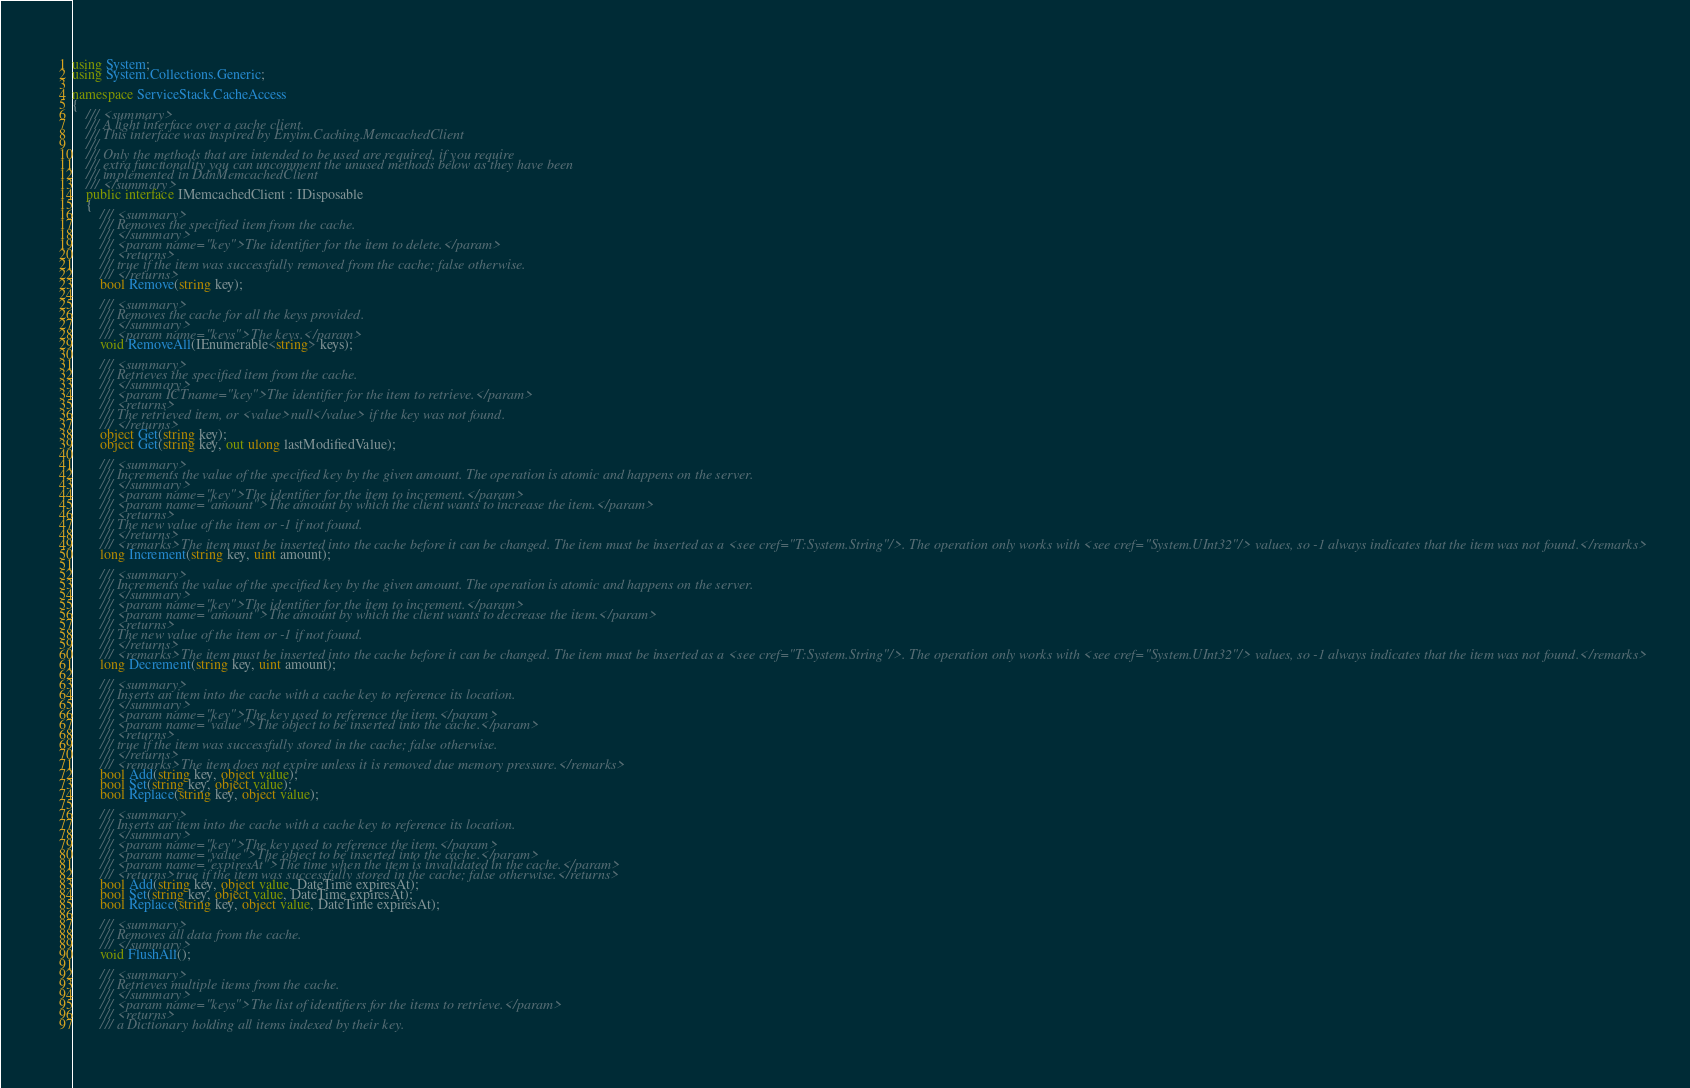Convert code to text. <code><loc_0><loc_0><loc_500><loc_500><_C#_>using System;
using System.Collections.Generic;

namespace ServiceStack.CacheAccess
{
	/// <summary>
	/// A light interface over a cache client.
	/// This interface was inspired by Enyim.Caching.MemcachedClient
	/// 
	/// Only the methods that are intended to be used are required, if you require
	/// extra functionality you can uncomment the unused methods below as they have been
	/// implemented in DdnMemcachedClient
	/// </summary>
	public interface IMemcachedClient : IDisposable
	{
		/// <summary>
		/// Removes the specified item from the cache.
		/// </summary>
		/// <param name="key">The identifier for the item to delete.</param>
		/// <returns>
		/// true if the item was successfully removed from the cache; false otherwise.
		/// </returns>
		bool Remove(string key);

		/// <summary>
		/// Removes the cache for all the keys provided.
		/// </summary>
		/// <param name="keys">The keys.</param>
		void RemoveAll(IEnumerable<string> keys);

		/// <summary>
		/// Retrieves the specified item from the cache.
		/// </summary>
		/// <param ICTname="key">The identifier for the item to retrieve.</param>
		/// <returns>
		/// The retrieved item, or <value>null</value> if the key was not found.
		/// </returns>
		object Get(string key);
		object Get(string key, out ulong lastModifiedValue);

		/// <summary>
		/// Increments the value of the specified key by the given amount. The operation is atomic and happens on the server.
		/// </summary>
		/// <param name="key">The identifier for the item to increment.</param>
		/// <param name="amount">The amount by which the client wants to increase the item.</param>
		/// <returns>
		/// The new value of the item or -1 if not found.
		/// </returns>
		/// <remarks>The item must be inserted into the cache before it can be changed. The item must be inserted as a <see cref="T:System.String"/>. The operation only works with <see cref="System.UInt32"/> values, so -1 always indicates that the item was not found.</remarks>
		long Increment(string key, uint amount);

		/// <summary>
		/// Increments the value of the specified key by the given amount. The operation is atomic and happens on the server.
		/// </summary>
		/// <param name="key">The identifier for the item to increment.</param>
		/// <param name="amount">The amount by which the client wants to decrease the item.</param>
		/// <returns>
		/// The new value of the item or -1 if not found.
		/// </returns>
		/// <remarks>The item must be inserted into the cache before it can be changed. The item must be inserted as a <see cref="T:System.String"/>. The operation only works with <see cref="System.UInt32"/> values, so -1 always indicates that the item was not found.</remarks>
		long Decrement(string key, uint amount);

		/// <summary>
		/// Inserts an item into the cache with a cache key to reference its location.
		/// </summary>
		/// <param name="key">The key used to reference the item.</param>
		/// <param name="value">The object to be inserted into the cache.</param>
		/// <returns>
		/// true if the item was successfully stored in the cache; false otherwise.
		/// </returns>
		/// <remarks>The item does not expire unless it is removed due memory pressure.</remarks>
		bool Add(string key, object value);
		bool Set(string key, object value);
		bool Replace(string key, object value);

		/// <summary>
		/// Inserts an item into the cache with a cache key to reference its location.
		/// </summary>
		/// <param name="key">The key used to reference the item.</param>
		/// <param name="value">The object to be inserted into the cache.</param>
		/// <param name="expiresAt">The time when the item is invalidated in the cache.</param>
		/// <returns>true if the item was successfully stored in the cache; false otherwise.</returns>
		bool Add(string key, object value, DateTime expiresAt);
		bool Set(string key, object value, DateTime expiresAt);
		bool Replace(string key, object value, DateTime expiresAt);

		/// <summary>
		/// Removes all data from the cache.
		/// </summary>
		void FlushAll();

		/// <summary>
		/// Retrieves multiple items from the cache.
		/// </summary>
		/// <param name="keys">The list of identifiers for the items to retrieve.</param>
		/// <returns>
		/// a Dictionary holding all items indexed by their key.</code> 